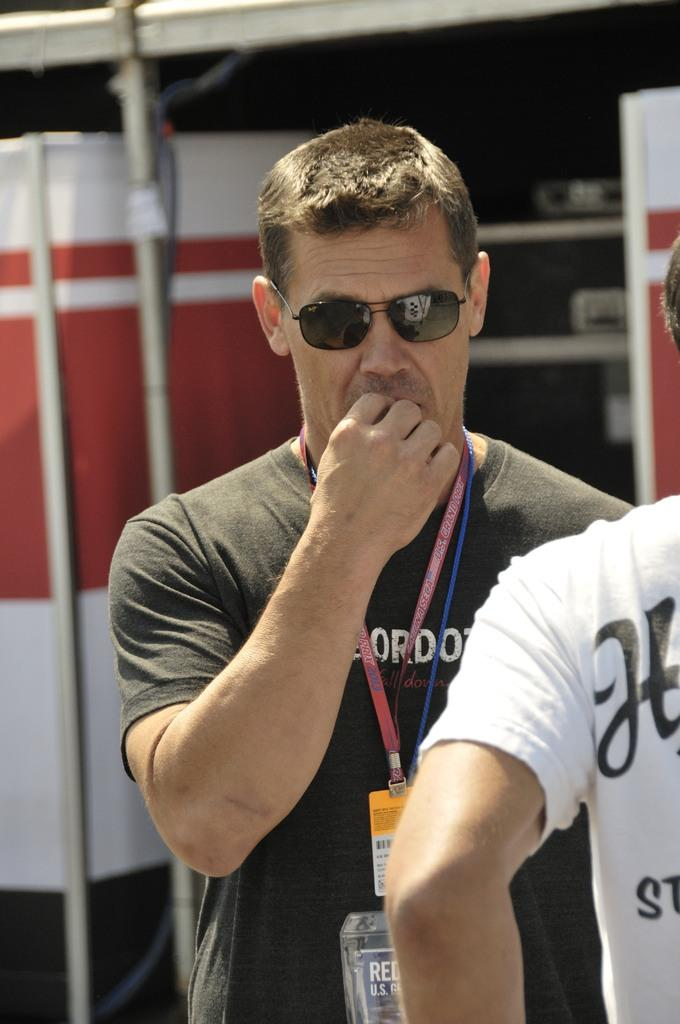Provide a one-sentence caption for the provided image. Both of the men have printing on their shirts which is unreadable. 